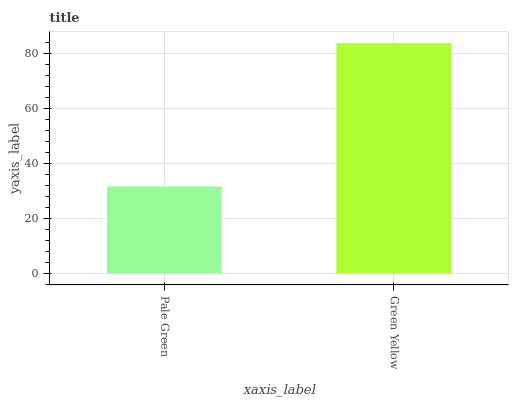Is Pale Green the minimum?
Answer yes or no. Yes. Is Green Yellow the maximum?
Answer yes or no. Yes. Is Green Yellow the minimum?
Answer yes or no. No. Is Green Yellow greater than Pale Green?
Answer yes or no. Yes. Is Pale Green less than Green Yellow?
Answer yes or no. Yes. Is Pale Green greater than Green Yellow?
Answer yes or no. No. Is Green Yellow less than Pale Green?
Answer yes or no. No. Is Green Yellow the high median?
Answer yes or no. Yes. Is Pale Green the low median?
Answer yes or no. Yes. Is Pale Green the high median?
Answer yes or no. No. Is Green Yellow the low median?
Answer yes or no. No. 